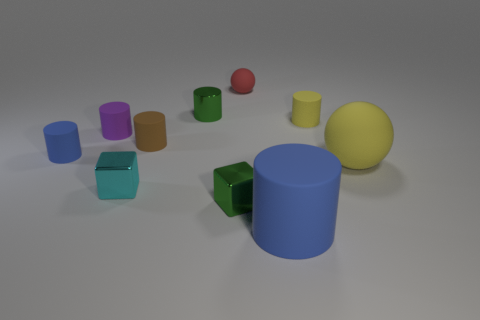Subtract all blue cylinders. How many cylinders are left? 4 Subtract all small green cylinders. How many cylinders are left? 5 Subtract all yellow cylinders. Subtract all red spheres. How many cylinders are left? 5 Subtract all cylinders. How many objects are left? 4 Subtract 0 red cubes. How many objects are left? 10 Subtract all tiny metallic blocks. Subtract all big blue matte objects. How many objects are left? 7 Add 5 tiny spheres. How many tiny spheres are left? 6 Add 5 large blue matte cylinders. How many large blue matte cylinders exist? 6 